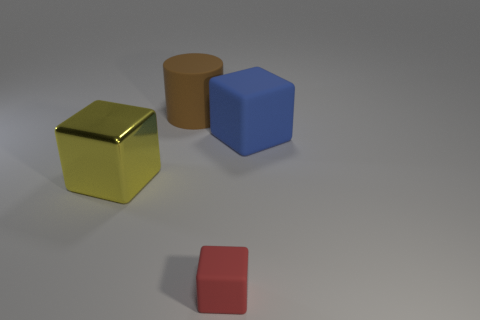There is a large thing that is to the right of the large metal cube and in front of the brown thing; what is its material?
Keep it short and to the point. Rubber. How many large objects are yellow shiny cubes or green shiny spheres?
Give a very brief answer. 1. How big is the shiny object?
Your response must be concise. Large. There is a brown thing; what shape is it?
Give a very brief answer. Cylinder. Are there any other things that have the same shape as the big blue object?
Make the answer very short. Yes. Is the number of big objects that are in front of the large yellow object less than the number of red blocks?
Ensure brevity in your answer.  Yes. Is the color of the matte thing on the left side of the tiny red cube the same as the large matte cube?
Your answer should be compact. No. How many metal things are big yellow objects or big brown things?
Keep it short and to the point. 1. Is there any other thing that has the same size as the brown matte cylinder?
Your answer should be compact. Yes. There is a small object that is made of the same material as the large blue object; what is its color?
Your answer should be compact. Red. 